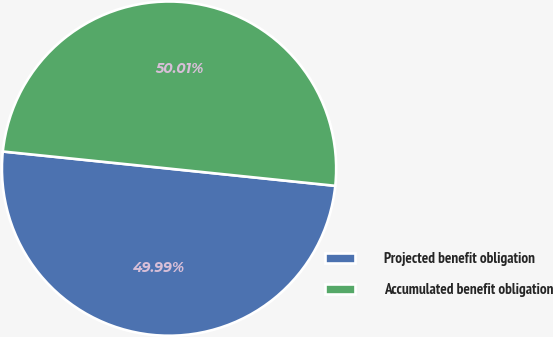<chart> <loc_0><loc_0><loc_500><loc_500><pie_chart><fcel>Projected benefit obligation<fcel>Accumulated benefit obligation<nl><fcel>49.99%<fcel>50.01%<nl></chart> 